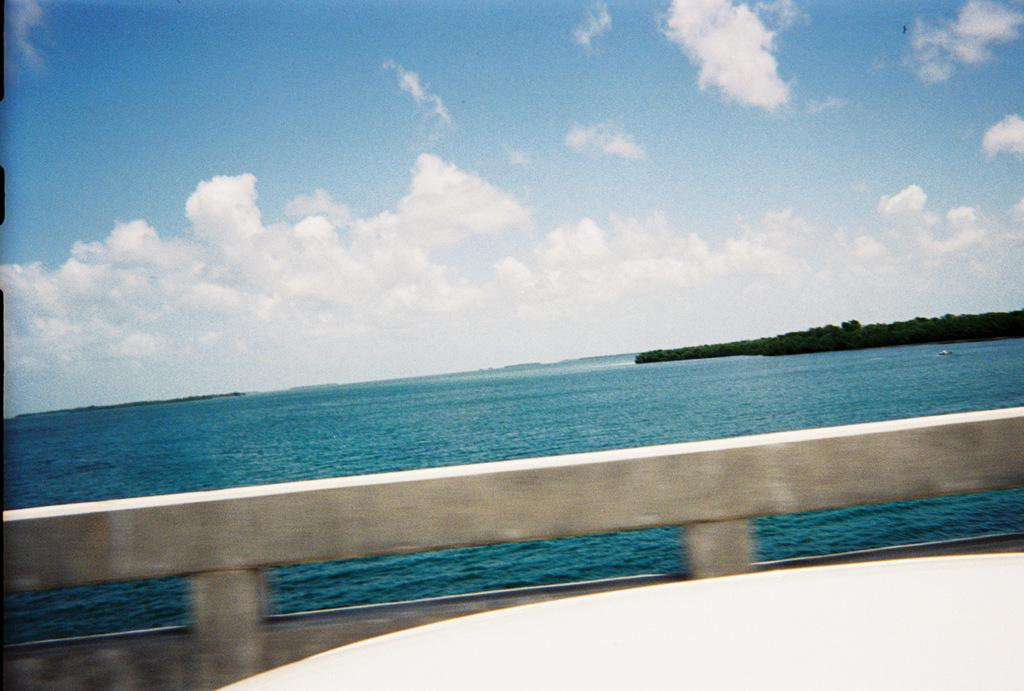What is the main object in the image? There is an object in the image, but its specific nature is not mentioned in the facts. What type of barrier can be seen in the image? There is a fence in the image. What natural element is visible in the image? Water is visible in the image. What type of vegetation is present in the image? There are trees in the image. What is visible in the background of the image? The sky is visible in the image, and clouds are present in the sky. What type of hair can be seen on the flock of fowl in the image? There is no mention of hair, flock, or fowl in the image. The image features an object, a fence, water, trees, and a sky with clouds, but no animals or hair are present. 